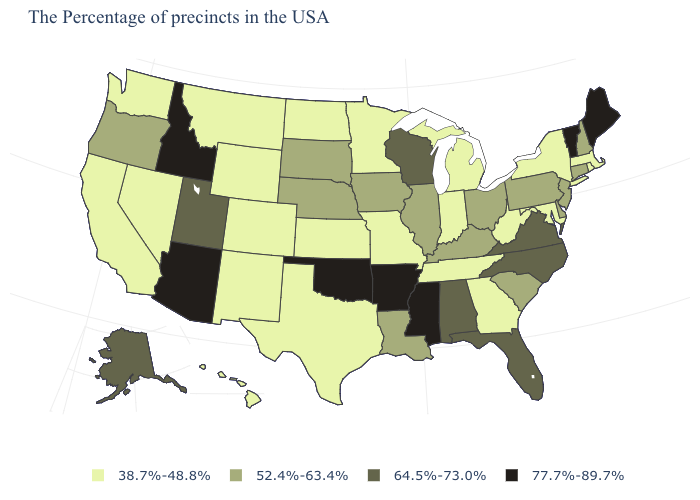Does Hawaii have the same value as Utah?
Keep it brief. No. How many symbols are there in the legend?
Short answer required. 4. Name the states that have a value in the range 64.5%-73.0%?
Short answer required. Virginia, North Carolina, Florida, Alabama, Wisconsin, Utah, Alaska. How many symbols are there in the legend?
Answer briefly. 4. Name the states that have a value in the range 52.4%-63.4%?
Be succinct. New Hampshire, Connecticut, New Jersey, Delaware, Pennsylvania, South Carolina, Ohio, Kentucky, Illinois, Louisiana, Iowa, Nebraska, South Dakota, Oregon. Name the states that have a value in the range 64.5%-73.0%?
Write a very short answer. Virginia, North Carolina, Florida, Alabama, Wisconsin, Utah, Alaska. Does Maine have the highest value in the USA?
Write a very short answer. Yes. Among the states that border Wisconsin , does Illinois have the lowest value?
Be succinct. No. What is the value of North Dakota?
Quick response, please. 38.7%-48.8%. Among the states that border North Carolina , does Georgia have the lowest value?
Short answer required. Yes. What is the highest value in states that border California?
Write a very short answer. 77.7%-89.7%. How many symbols are there in the legend?
Keep it brief. 4. Does Arizona have the same value as Mississippi?
Keep it brief. Yes. What is the value of Arkansas?
Write a very short answer. 77.7%-89.7%. Does Texas have the lowest value in the USA?
Concise answer only. Yes. 